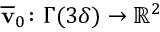Convert formula to latex. <formula><loc_0><loc_0><loc_500><loc_500>\overline { v } _ { 0 } \colon \Gamma ( 3 \delta ) \to { \mathbb { R } } ^ { 2 }</formula> 